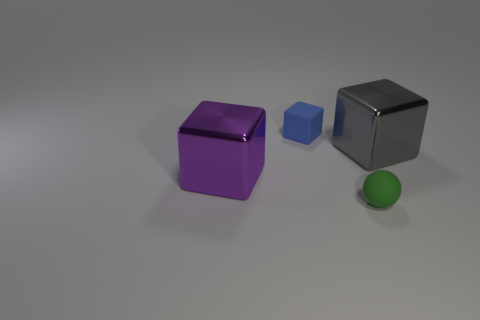Subtract all small blocks. How many blocks are left? 2 Subtract 1 balls. How many balls are left? 0 Subtract all red cylinders. How many brown blocks are left? 0 Add 1 big gray matte spheres. How many objects exist? 5 Subtract all blocks. How many objects are left? 1 Subtract all gray things. Subtract all small blue things. How many objects are left? 2 Add 2 large shiny blocks. How many large shiny blocks are left? 4 Add 4 large purple shiny objects. How many large purple shiny objects exist? 5 Subtract 0 cyan cubes. How many objects are left? 4 Subtract all blue balls. Subtract all cyan cylinders. How many balls are left? 1 